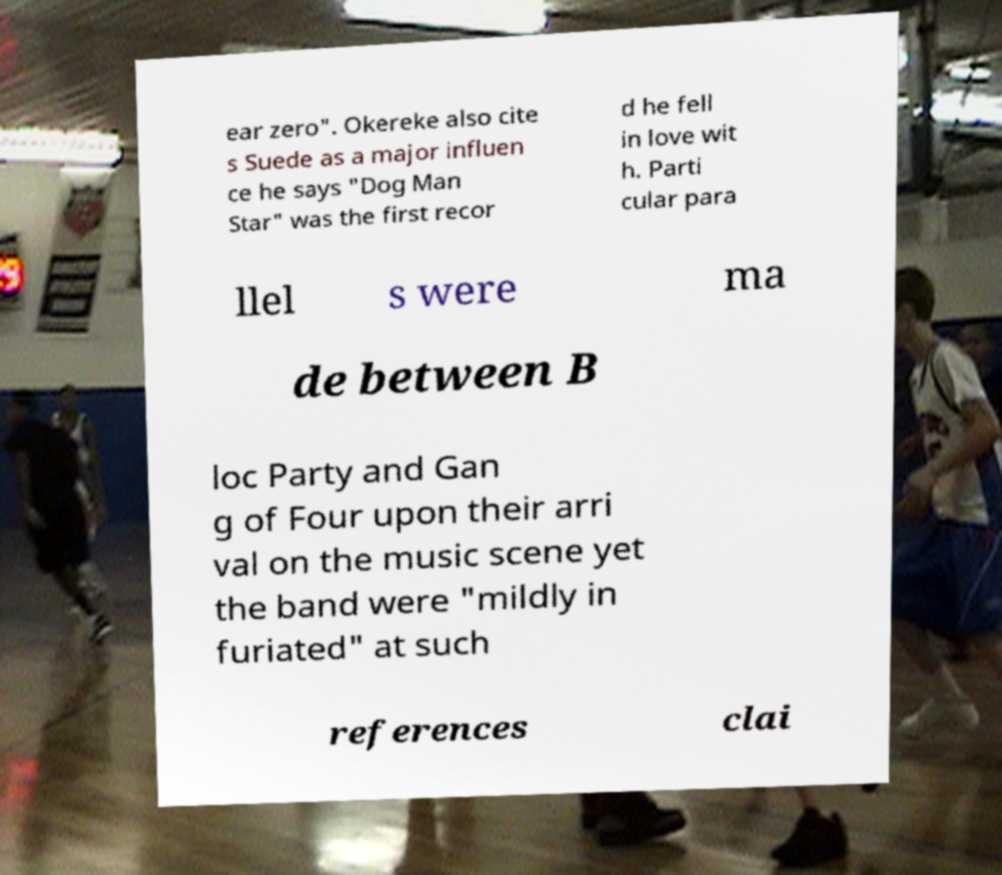What messages or text are displayed in this image? I need them in a readable, typed format. ear zero". Okereke also cite s Suede as a major influen ce he says "Dog Man Star" was the first recor d he fell in love wit h. Parti cular para llel s were ma de between B loc Party and Gan g of Four upon their arri val on the music scene yet the band were "mildly in furiated" at such references clai 